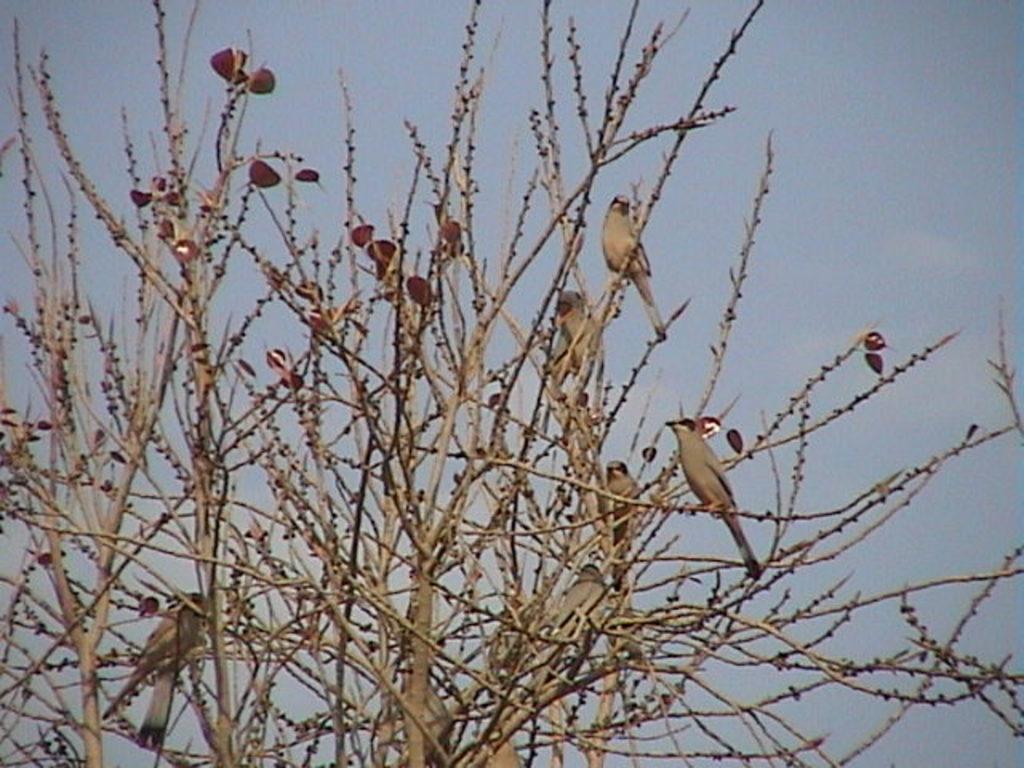How would you summarize this image in a sentence or two? In this image we can see birds on the tree. In the background there is a sky. 